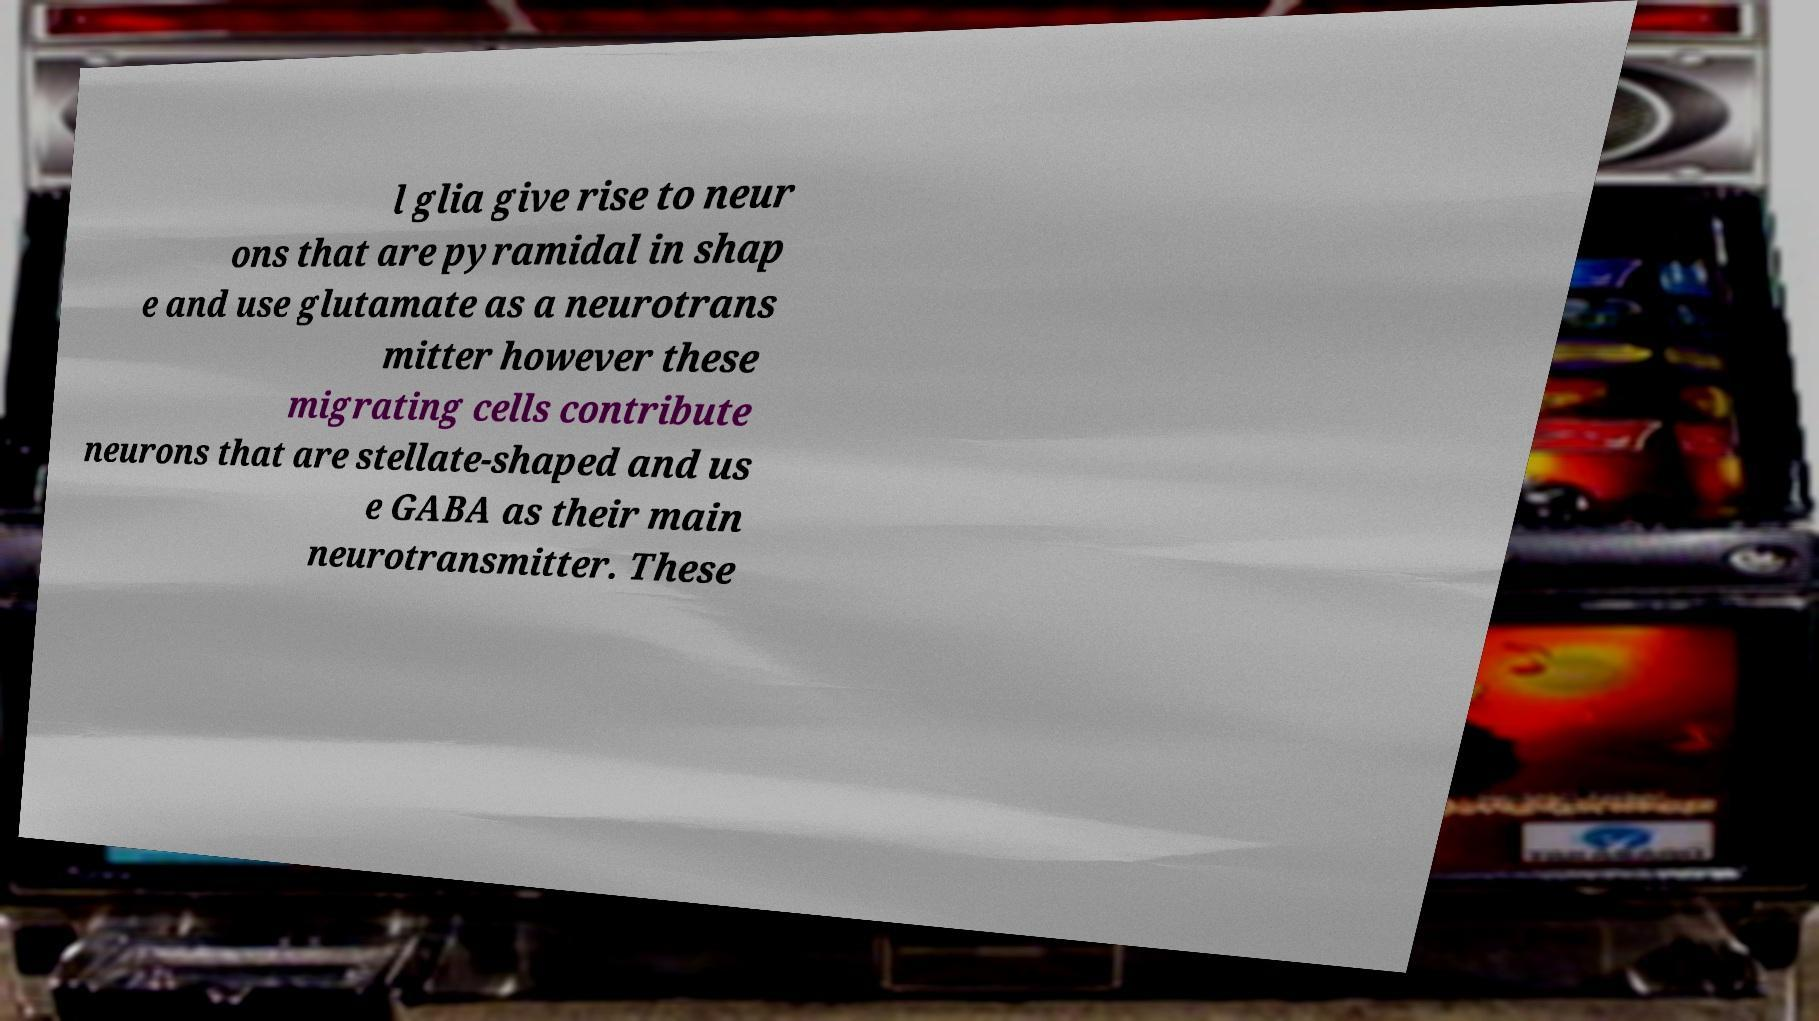Could you assist in decoding the text presented in this image and type it out clearly? l glia give rise to neur ons that are pyramidal in shap e and use glutamate as a neurotrans mitter however these migrating cells contribute neurons that are stellate-shaped and us e GABA as their main neurotransmitter. These 